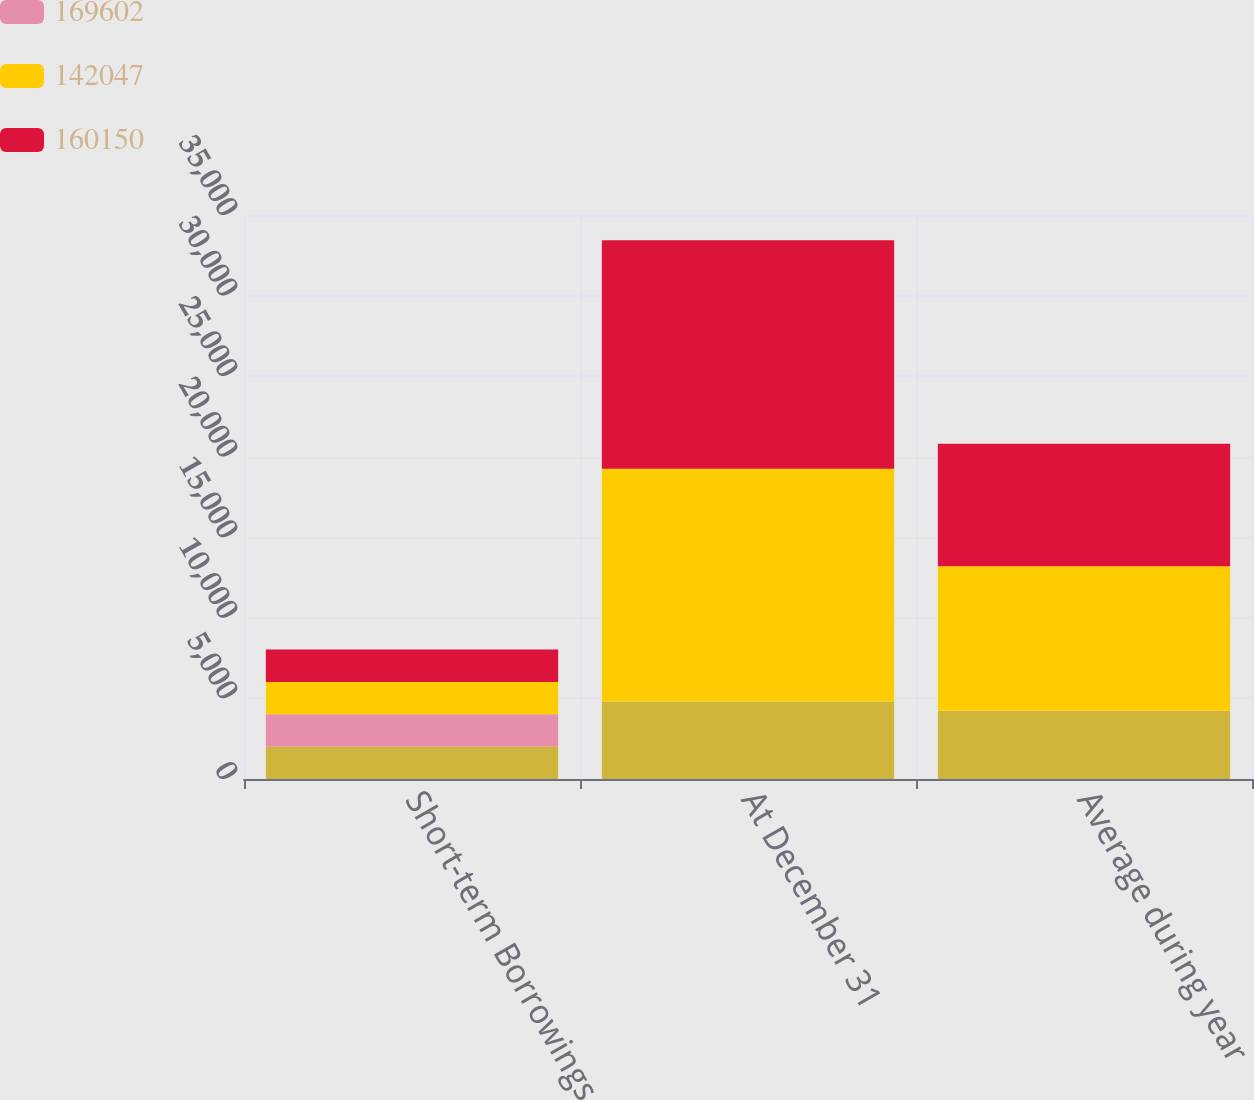<chart> <loc_0><loc_0><loc_500><loc_500><stacked_bar_chart><ecel><fcel>Short-term Borrowings<fcel>At December 31<fcel>Average during year<nl><fcel>nan<fcel>2009<fcel>4814<fcel>4239<nl><fcel>169602<fcel>2009<fcel>0.09<fcel>0.05<nl><fcel>142047<fcel>2008<fcel>14432<fcel>8969<nl><fcel>160150<fcel>2007<fcel>14187<fcel>7595<nl></chart> 